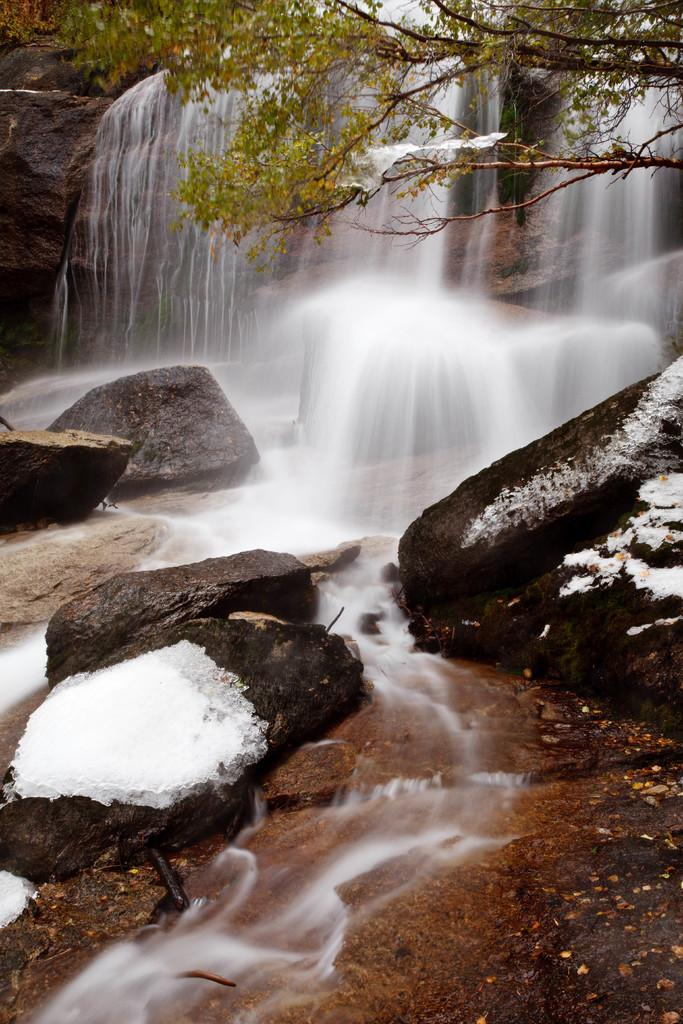What natural feature is the main subject of the image? There is a waterfall in the image. What type of vegetation can be seen in the image? There is a tree on the top right side of the image. What type of geological formation is visible in the image? There are rocks visible in the image. What book is the mice reading in the image? There is no book or mice present in the image; it features a waterfall, a tree, and rocks. 